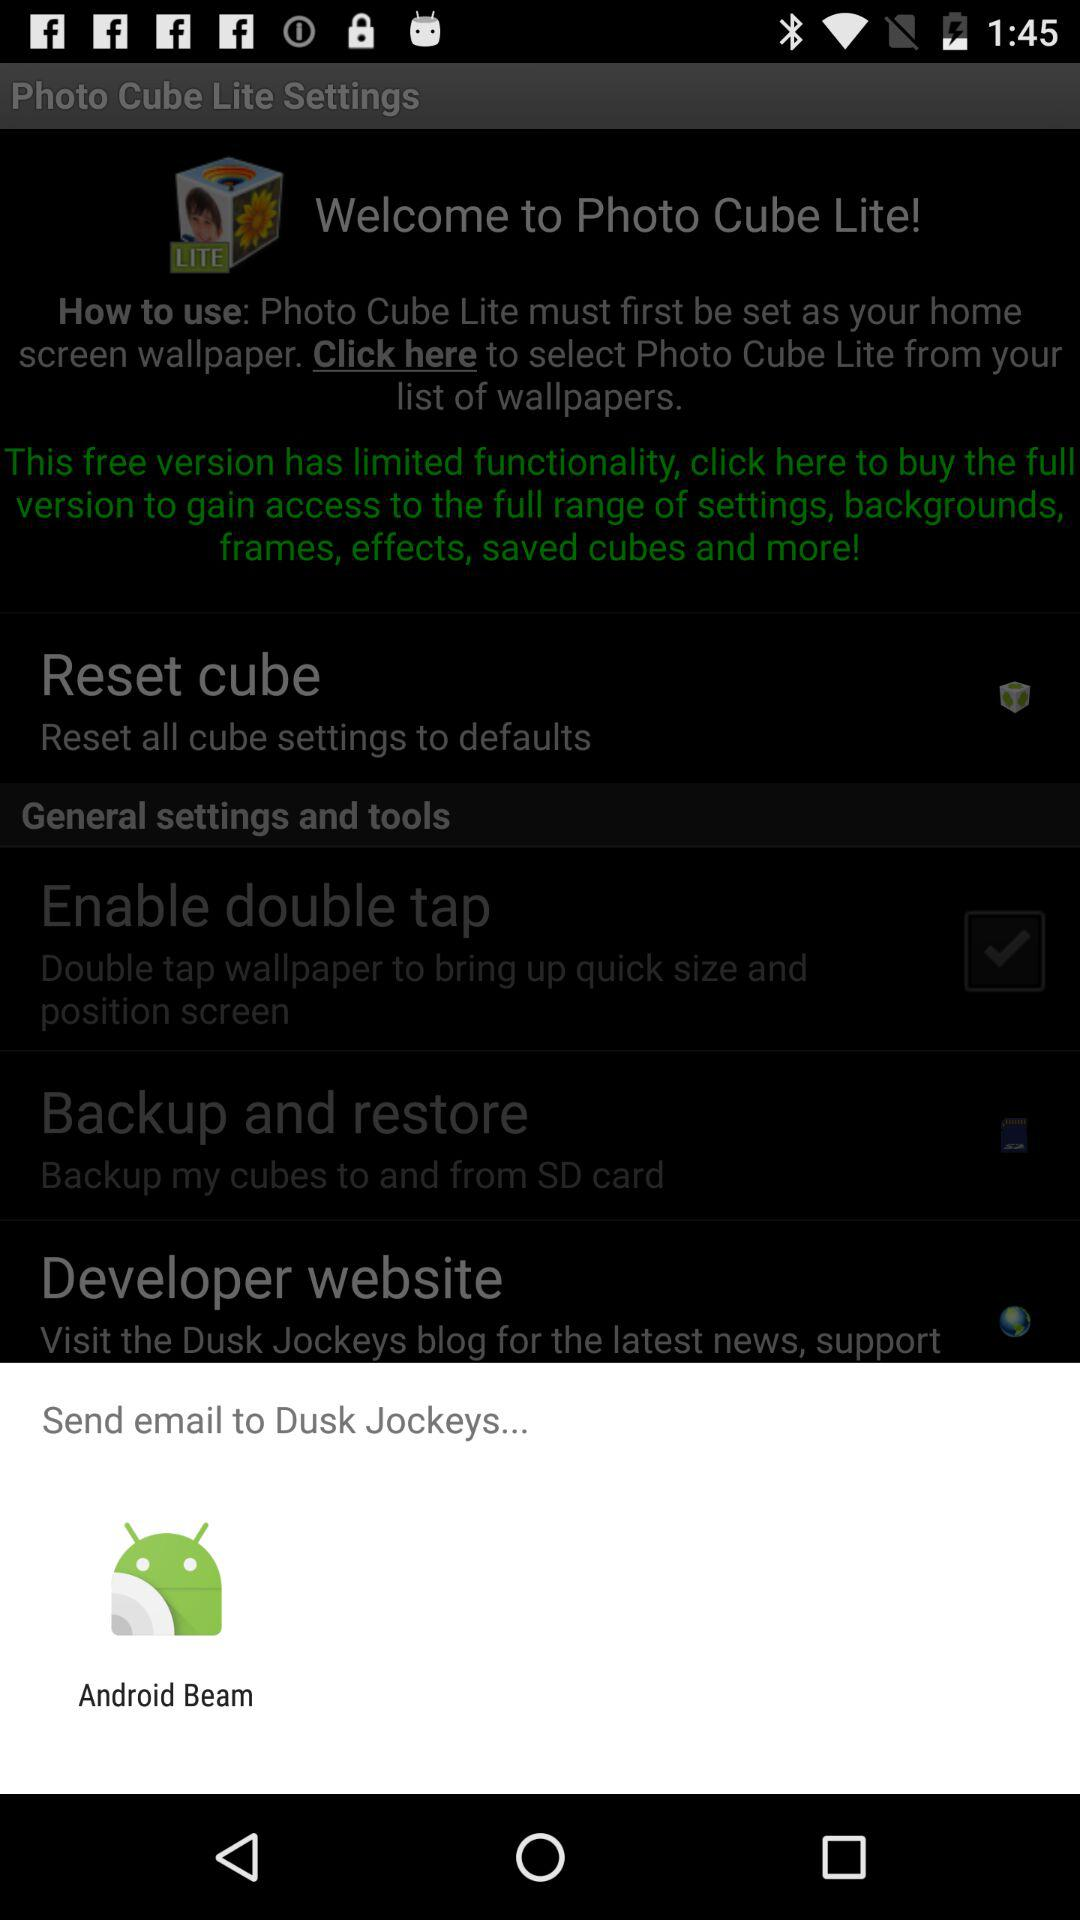Where can I share this application? You can share it through "Android Beam". 